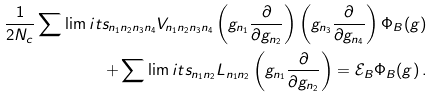Convert formula to latex. <formula><loc_0><loc_0><loc_500><loc_500>\frac { 1 } { 2 N _ { c } } \sum \lim i t s _ { n _ { 1 } n _ { 2 } n _ { 3 } n _ { 4 } } V _ { n _ { 1 } n _ { 2 } n _ { 3 } n _ { 4 } } \left ( g _ { n _ { 1 } } \frac { \partial } { \partial g _ { n _ { 2 } } } \right ) \left ( g _ { n _ { 3 } } \frac { \partial } { \partial g _ { n _ { 4 } } } \right ) \Phi _ { B } ( g ) \\ + \sum \lim i t s _ { n _ { 1 } n _ { 2 } } L _ { n _ { 1 } n _ { 2 } } \left ( g _ { n _ { 1 } } \frac { \partial } { \partial g _ { n _ { 2 } } } \right ) = \mathcal { E } _ { B } \Phi _ { B } ( g ) \, .</formula> 